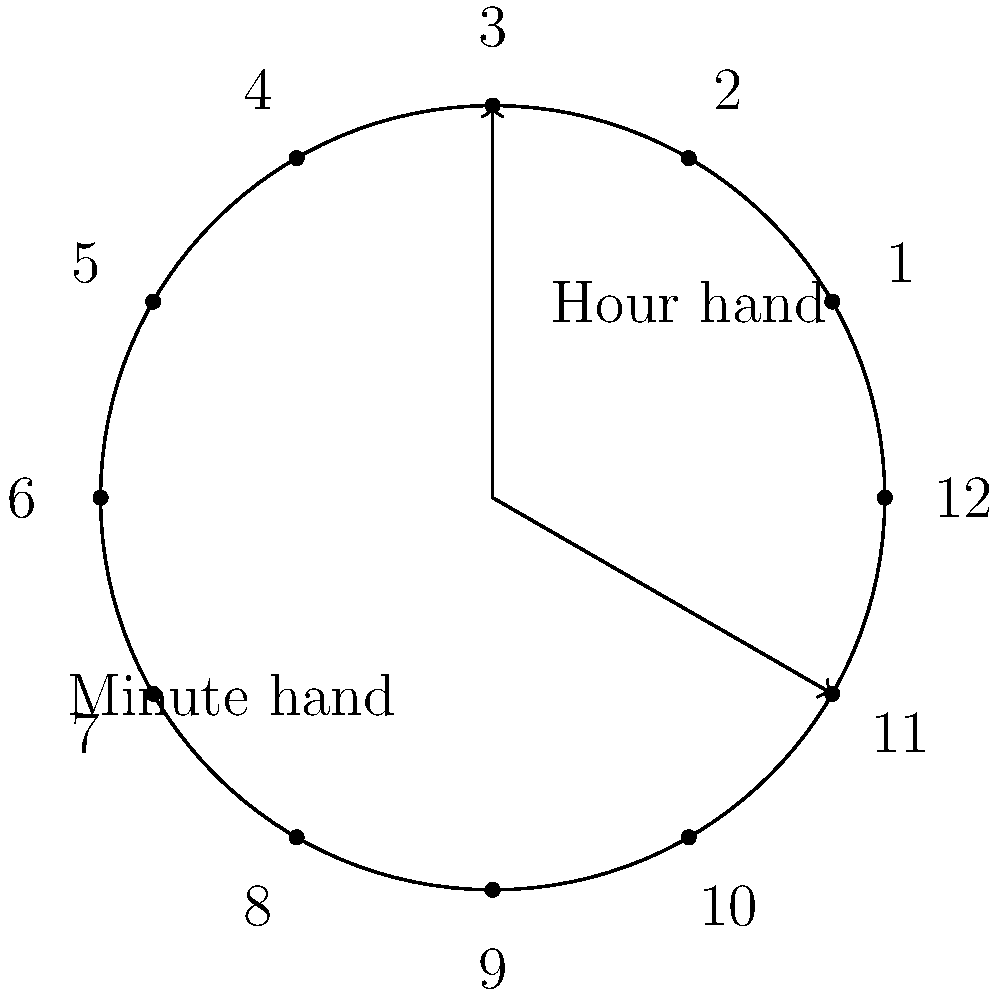In the courthouse where you and Sandy Dawson often work, there's an analog clock with both hour and minute hands. Considering the positions of both hands as elements of a cyclic group, what is the order of this group? Assume the clock shows only whole hours (i.e., the hour hand moves discretely). To determine the order of the cyclic group formed by the clock hands, we need to consider the following steps:

1. The hour hand has 12 distinct positions (1 to 12).
2. The minute hand also has 12 distinct positions (5-minute intervals).
3. We need to find the least common multiple (LCM) of the number of positions for each hand to determine how many unique combinations exist before the pattern repeats.

4. In this case, both hands have 12 positions, so:
   $$ LCM(12, 12) = 12 $$

5. However, we need to consider that for each hour hand position, the minute hand completes a full rotation. This means we multiply the LCM by 12:
   $$ 12 \times 12 = 144 $$

6. Therefore, there are 144 unique positions before the clock hands return to their original configuration.

In group theory, the number of elements in a cyclic group is its order. Thus, the order of the cyclic group formed by the clock hands is 144.
Answer: 144 